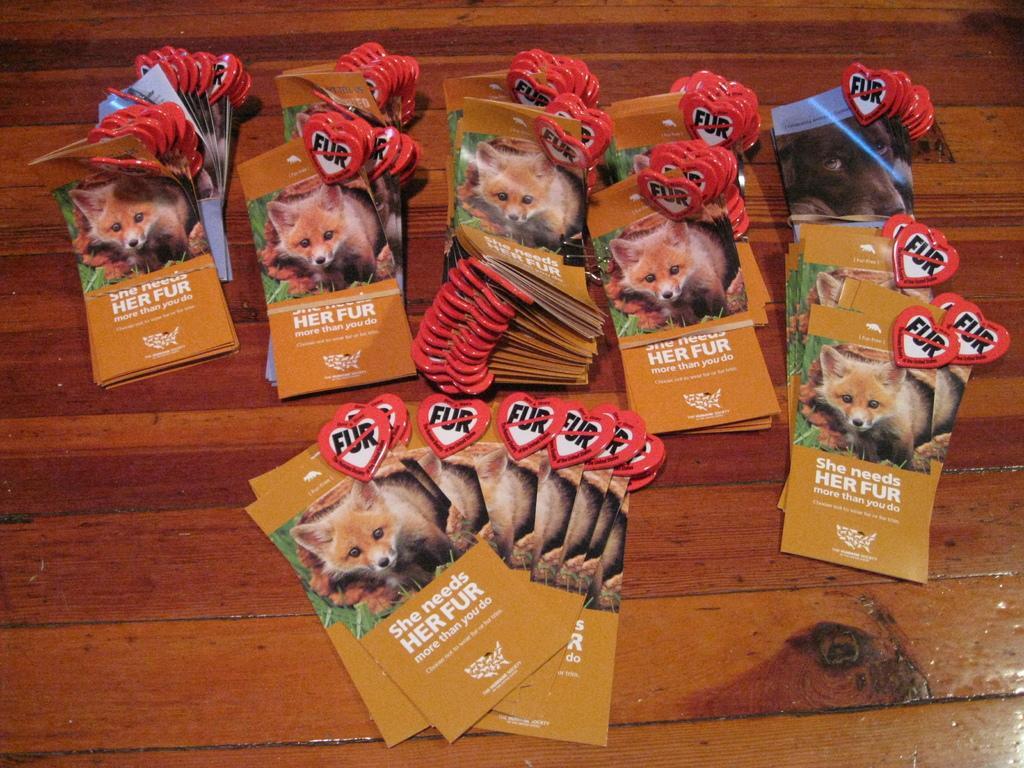In one or two sentences, can you explain what this image depicts? In this image there are cards, there is an animal on the card, there is text on the cards, at the background of the image there is a wooden object that looks like a table. 